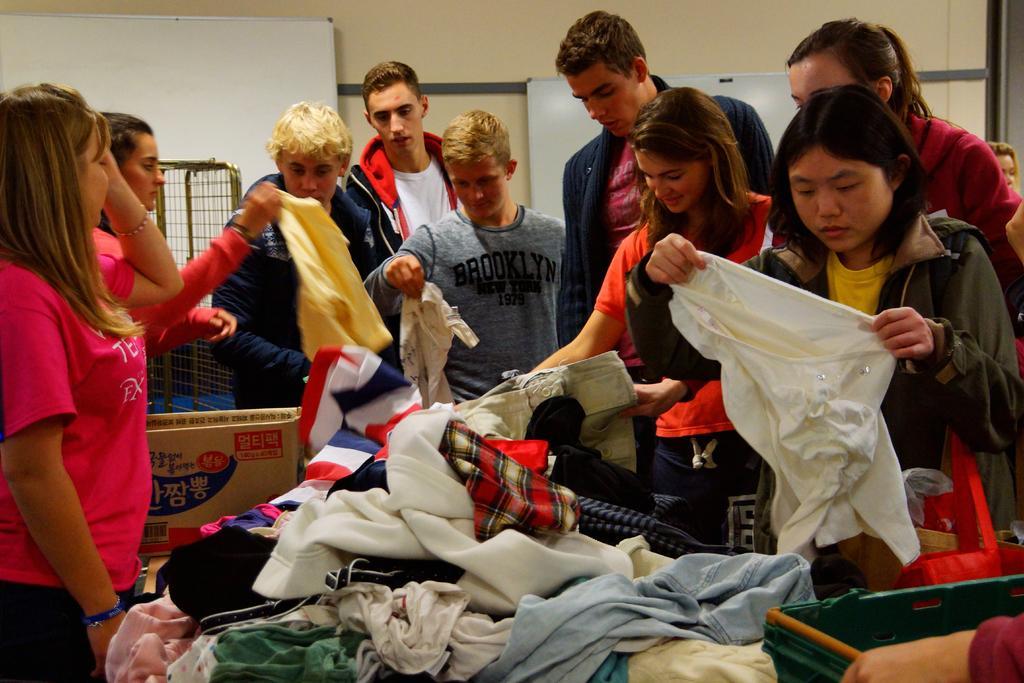How would you summarize this image in a sentence or two? This image is taken indoors. In the background there is a wall and there are two boards. On the left side of the image two women are standing and there is a cardboard box and a mesh. At the bottom of the image there are many clothes and a basket on the table. On the right side of the image a person is holding a basket and a woman is holding a shirt in her hands. In the middle of the image a few people are standing. 